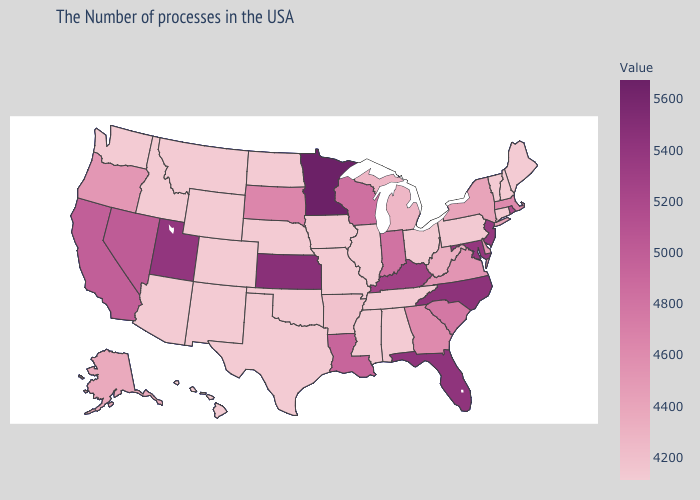Among the states that border Mississippi , does Louisiana have the highest value?
Keep it brief. Yes. Which states have the lowest value in the USA?
Keep it brief. Maine, New Hampshire, Vermont, Connecticut, Ohio, Alabama, Tennessee, Illinois, Mississippi, Missouri, Iowa, Nebraska, Oklahoma, Texas, North Dakota, Wyoming, Colorado, New Mexico, Montana, Arizona, Idaho, Washington, Hawaii. Among the states that border Kentucky , which have the lowest value?
Write a very short answer. Ohio, Tennessee, Illinois, Missouri. Does the map have missing data?
Quick response, please. No. Does Minnesota have the highest value in the USA?
Be succinct. Yes. Which states have the highest value in the USA?
Quick response, please. Minnesota. 